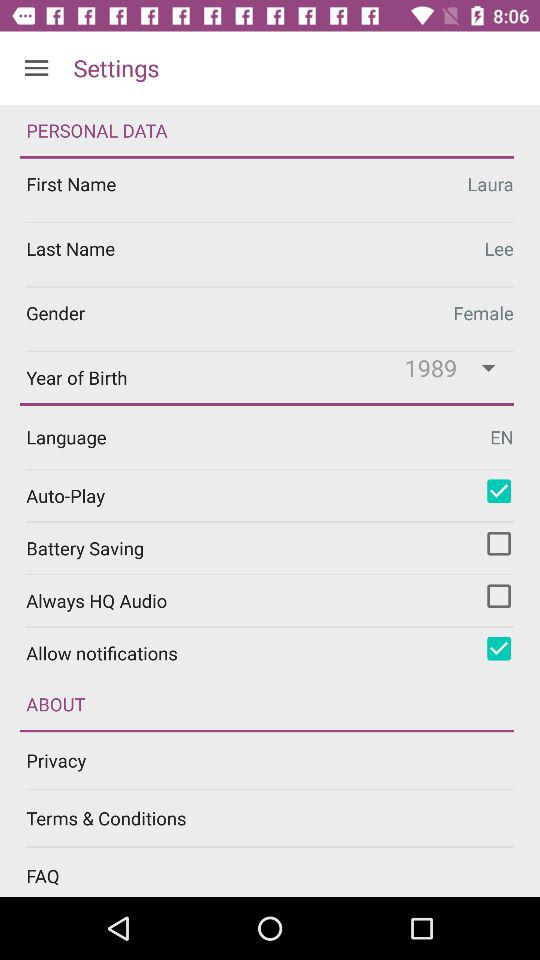What is the year of birth of the user? The year of birth of the user is 1989. 